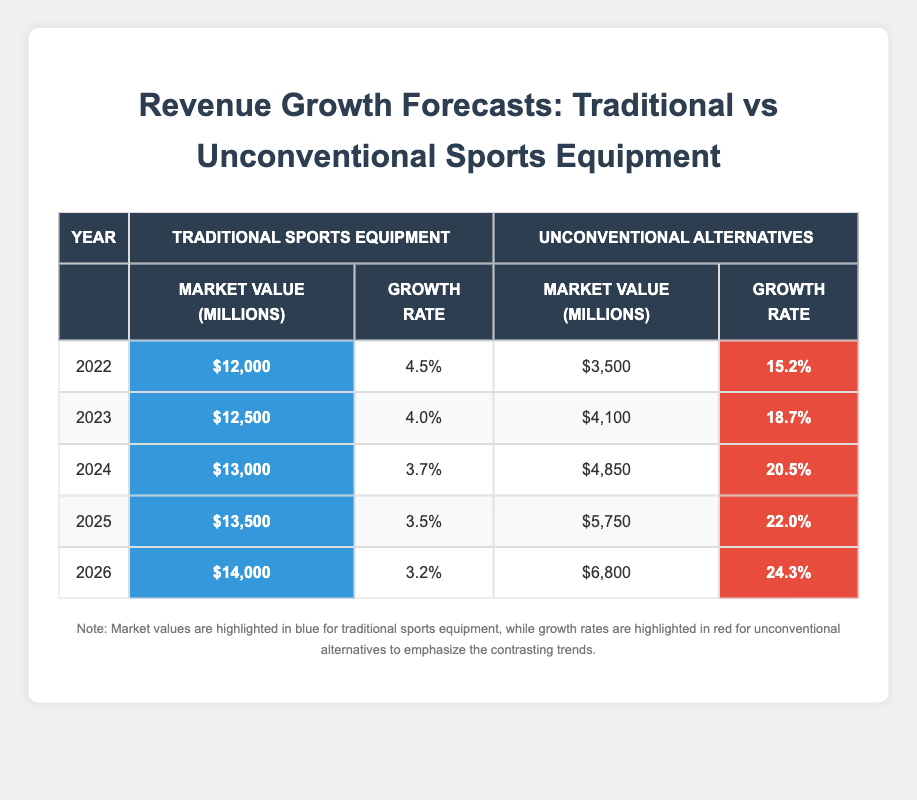What was the market value for traditional sports equipment in 2022? The table shows the market value for traditional sports equipment in 2022, which is highlighted in blue. According to the table, it is 12,000 million dollars.
Answer: 12,000 million What is the growth rate for unconventional alternatives in 2023? Looking at the 2023 row in the table, the growth rate for unconventional alternatives is highlighted in red, and it shows a value of 18.7 percent.
Answer: 18.7 percent What is the difference in market value between traditional sports equipment and unconventional alternatives in 2024? In 2024, traditional sports equipment has a market value of 13,000 million and unconventional alternatives have a market value of 4,850 million. The difference is calculated as 13,000 - 4,850 = 8,150 million.
Answer: 8,150 million What was the average growth rate for traditional sports equipment from 2022 to 2026? The growth rates for traditional sports equipment from 2022 to 2026 are 4.5, 4.0, 3.7, 3.5, and 3.2 percent. Calculating the average: (4.5 + 4.0 + 3.7 + 3.5 + 3.2) / 5 = 18.9 / 5 = 3.78 percent.
Answer: 3.78 percent Did the market value for unconventional alternatives ever exceed that of traditional sports equipment? Looking at each year's market values in the table, traditional sports equipment's values are consistently higher than those of unconventional alternatives from 2022 to 2026. Thus, the statement is false.
Answer: No What year had the highest growth rate for unconventional alternatives? By examining the growth rates for unconventional alternatives in the table, the rates are 15.2, 18.7, 20.5, 22.0, and 24.3 percent for the years 2022 to 2026. The highest growth rate is 24.3 percent in 2026.
Answer: 2026 What is the cumulative market value for traditional sports equipment between 2022 and 2025? The market values for traditional sports equipment from 2022 to 2025 are 12,000, 12,500, 13,000, and 13,500 million. Summing these values gives 12,000 + 12,500 + 13,000 + 13,500 = 51,000 million.
Answer: 51,000 million What trend can be observed in the growth rates for traditional sports equipment from 2022 to 2026? Reviewing the table, the growth rates for traditional sports equipment consistently decrease from 4.5% in 2022 to 3.2% in 2026. This indicates a downward trend in growth rate over the years.
Answer: Decreasing trend 